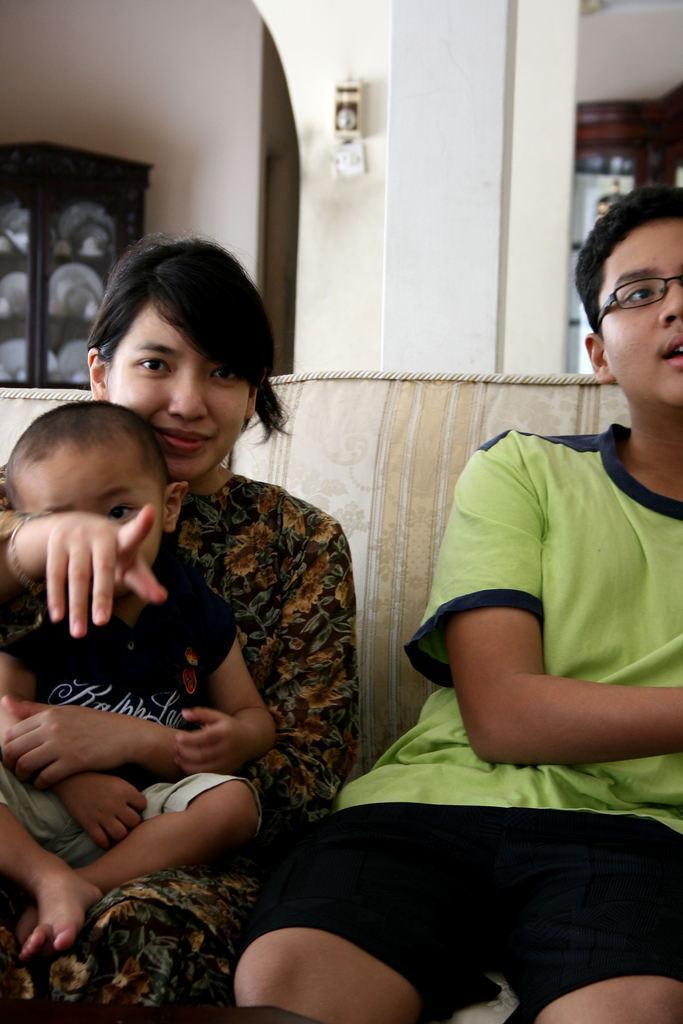In one or two sentences, can you explain what this image depicts? In this image, there are a few people sitting on an object. We can also see the wall and some wooden objects. We can also see a pillar with some object attached to it. 